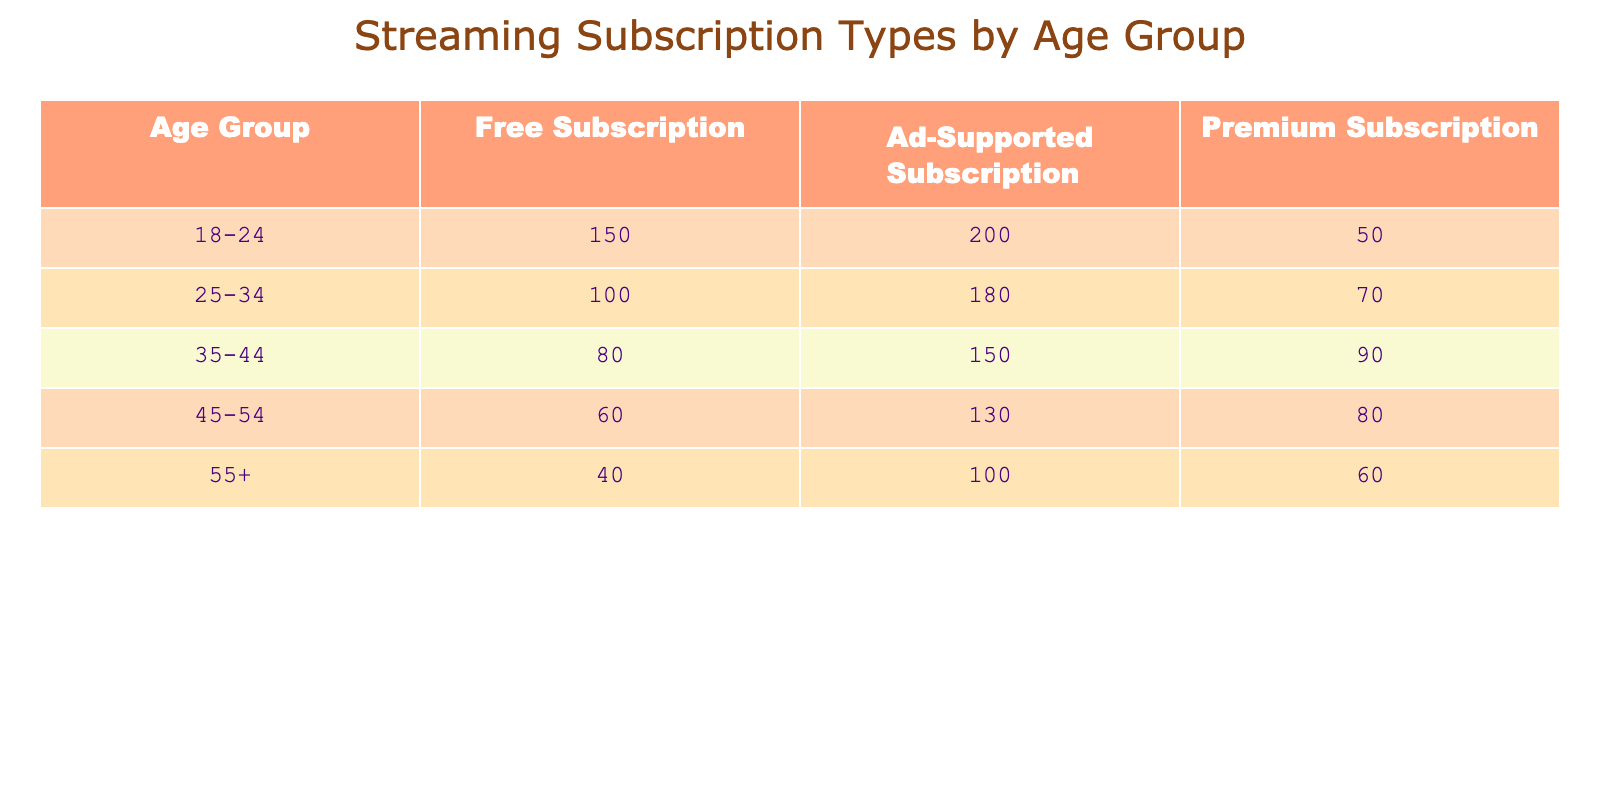What is the total number of people in the 25-34 age group with Premium subscriptions? Looking at the table, the number of people in the 25-34 age group who have Premium subscriptions is 70. Therefore, that's the answer.
Answer: 70 Which age group has the highest number of Free subscriptions? According to the table, the highest number of Free subscriptions is in the 18-24 age group with 150 subscriptions.
Answer: 18-24 Is the number of Ad-Supported subscriptions for the 55+ age group greater than that for the 35-44 age group? The number of Ad-Supported subscriptions for the 55+ age group is 100, while for the 35-44 age group, it is 150. Since 100 is not greater than 150, the answer is no.
Answer: No What is the total number of subscriptions across all types for the 45-54 age group? We sum the subscriptions for the 45-54 age group: Free (60) + Ad-Supported (130) + Premium (80) = 270. Thus, the total number of subscriptions for this age group is 270.
Answer: 270 Which subscription type is most popular among the 35-44 age group? The Ad-Supported subscription is most popular in the 35-44 age group, with 150 subscriptions, compared to Free (80) and Premium (90).
Answer: Ad-Supported What is the average number of Ad-Supported subscriptions across all age groups? To find the average, we add the Ad-Supported subscriptions for all age groups: 200 + 180 + 150 + 130 + 100 = 760. There are 5 groups, so the average is 760 / 5 = 152.
Answer: 152 Is it true that the number of Free subscriptions in the 55+ age group is less than the number in the 45-54 age group? The Free subscriptions in the 55+ age group is 40, and for the 45-54 age group, it is 60. Since 40 is less than 60, the statement is true.
Answer: Yes Which subscription type has the least number of subscriptions overall? To find this, we sum up each type: Free (150 + 100 + 80 + 60 + 40 = 430), Ad-Supported (200 + 180 + 150 + 130 + 100 = 760), Premium (50 + 70 + 90 + 80 + 60 = 350). The least is the Premium subscriptions with a total of 350.
Answer: Premium If we compare the total number of Premium subscriptions to Free subscriptions, which is higher? We already calculated the totals: Premium subscriptions = 350, Free subscriptions = 430. Since 430 is greater than 350, Free subscriptions are higher.
Answer: Free 